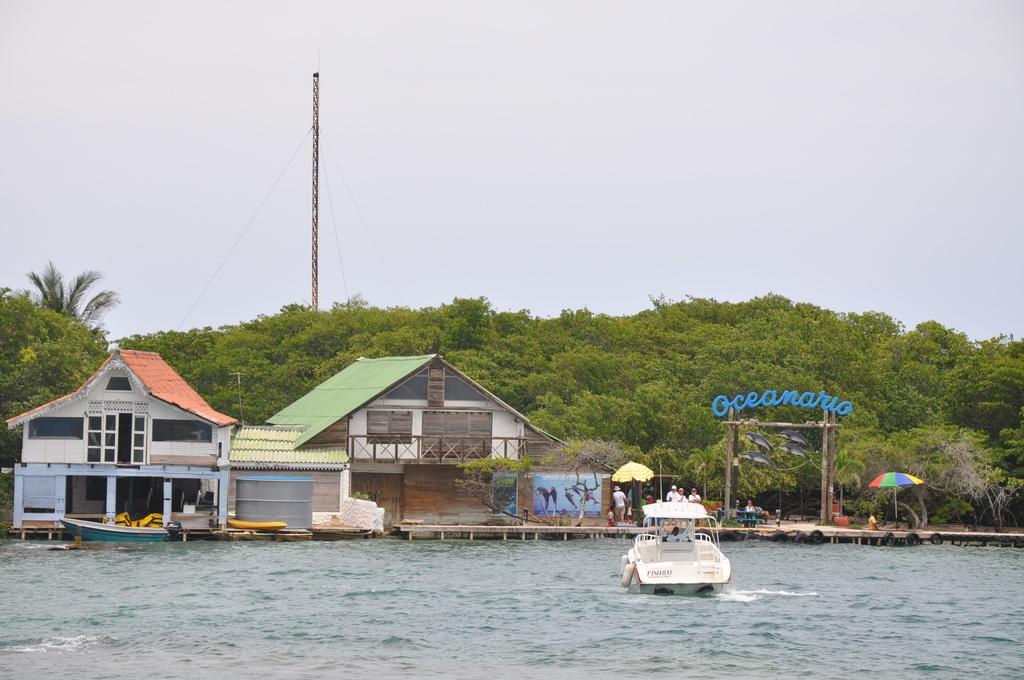In one or two sentences, can you explain what this image depicts? In this picture I can see a person in the boat. I can see another boat in the water. There are a few houses, umbrella, some people poster and other objects are visible on the walkway. I can see some trees and a pole in the background. To his pole, I can see a few wires. 